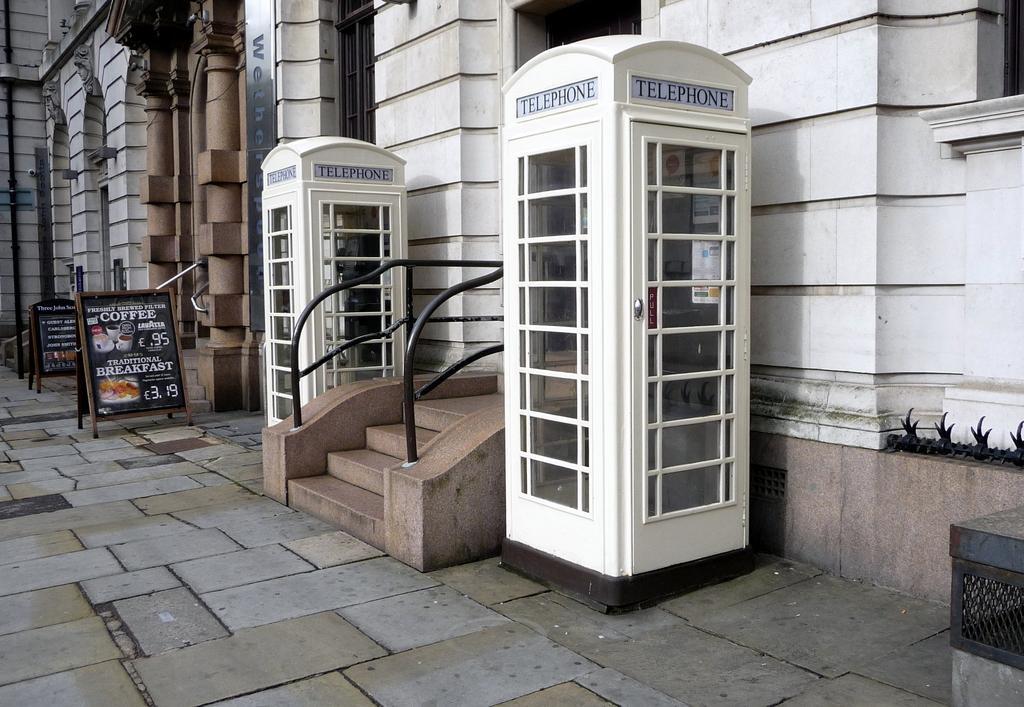Describe this image in one or two sentences. In the middle of the image there are some telephone booths and banners. Behind them there is a building. 